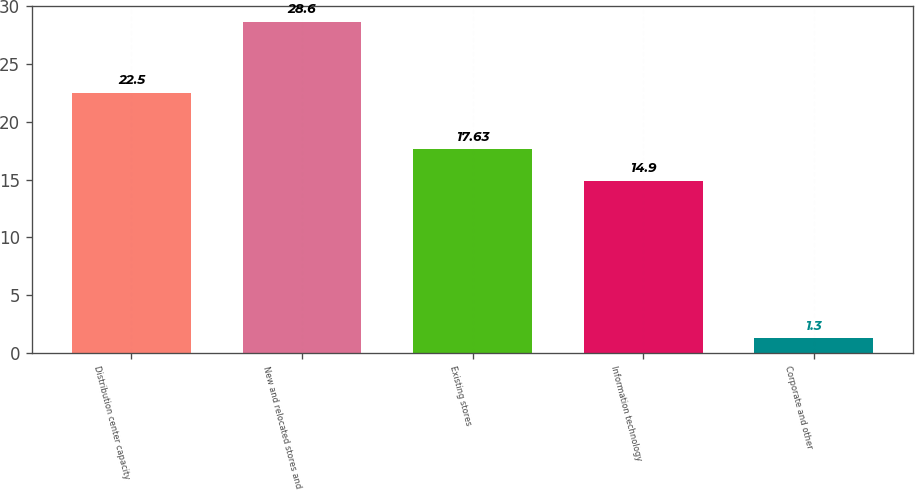<chart> <loc_0><loc_0><loc_500><loc_500><bar_chart><fcel>Distribution center capacity<fcel>New and relocated stores and<fcel>Existing stores<fcel>Information technology<fcel>Corporate and other<nl><fcel>22.5<fcel>28.6<fcel>17.63<fcel>14.9<fcel>1.3<nl></chart> 